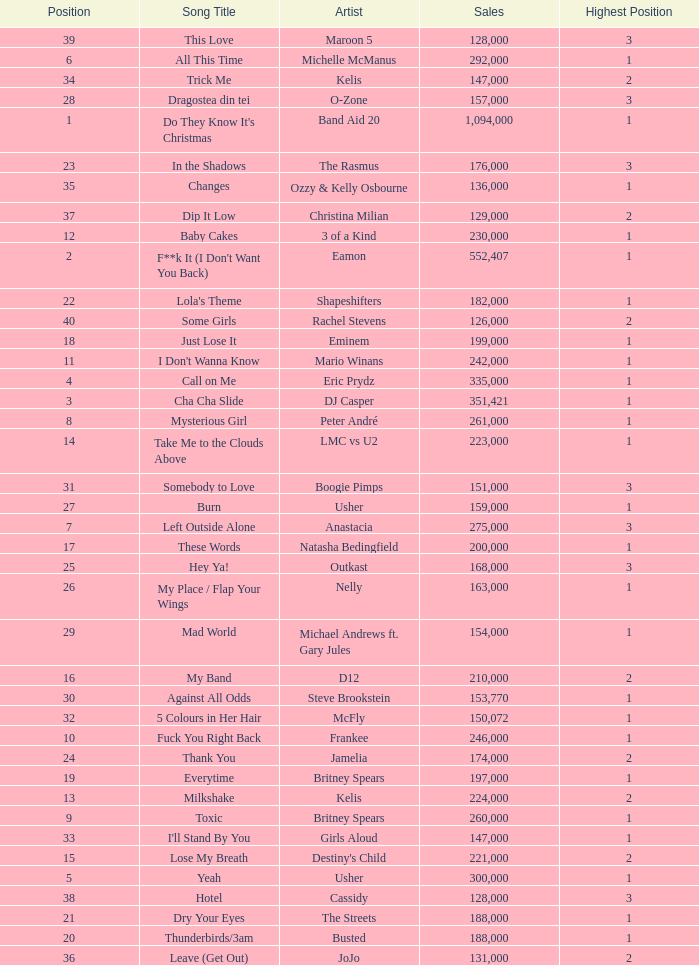What were the sales for Dj Casper when he was in a position lower than 13? 351421.0. 